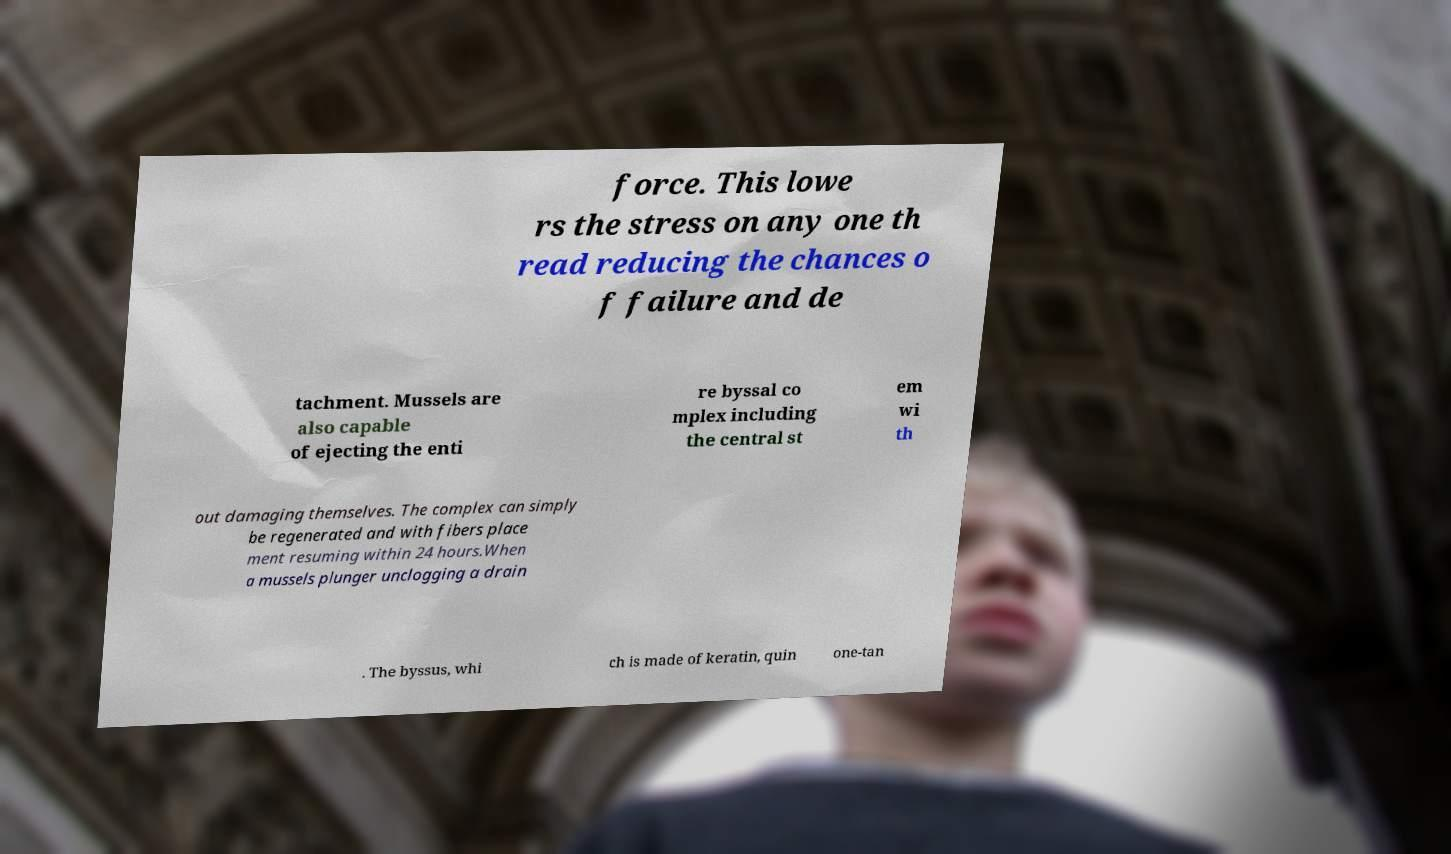For documentation purposes, I need the text within this image transcribed. Could you provide that? force. This lowe rs the stress on any one th read reducing the chances o f failure and de tachment. Mussels are also capable of ejecting the enti re byssal co mplex including the central st em wi th out damaging themselves. The complex can simply be regenerated and with fibers place ment resuming within 24 hours.When a mussels plunger unclogging a drain . The byssus, whi ch is made of keratin, quin one-tan 